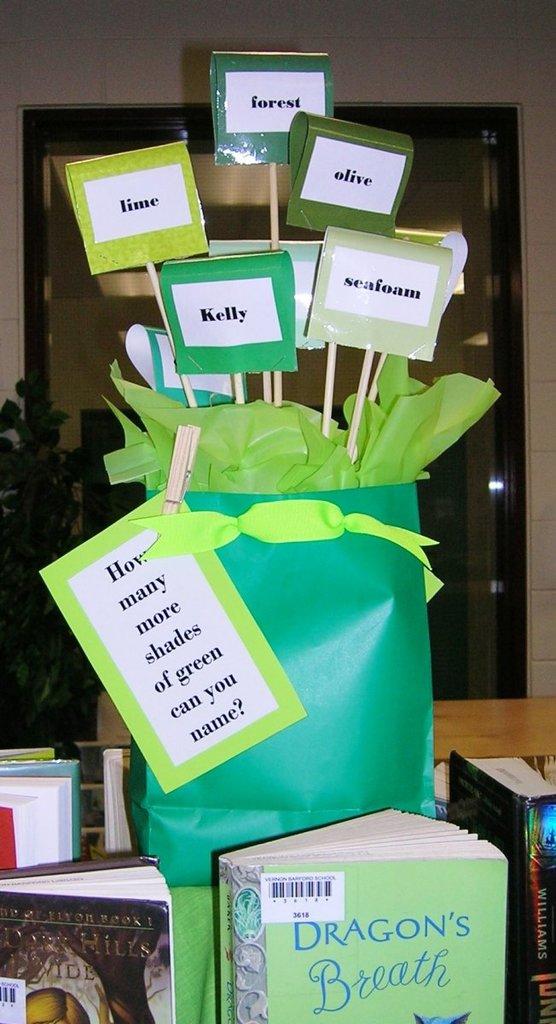How many shades of green are named?
Your answer should be compact. 5. What's the title of the book at the bottom?
Keep it short and to the point. Dragon's breath. 